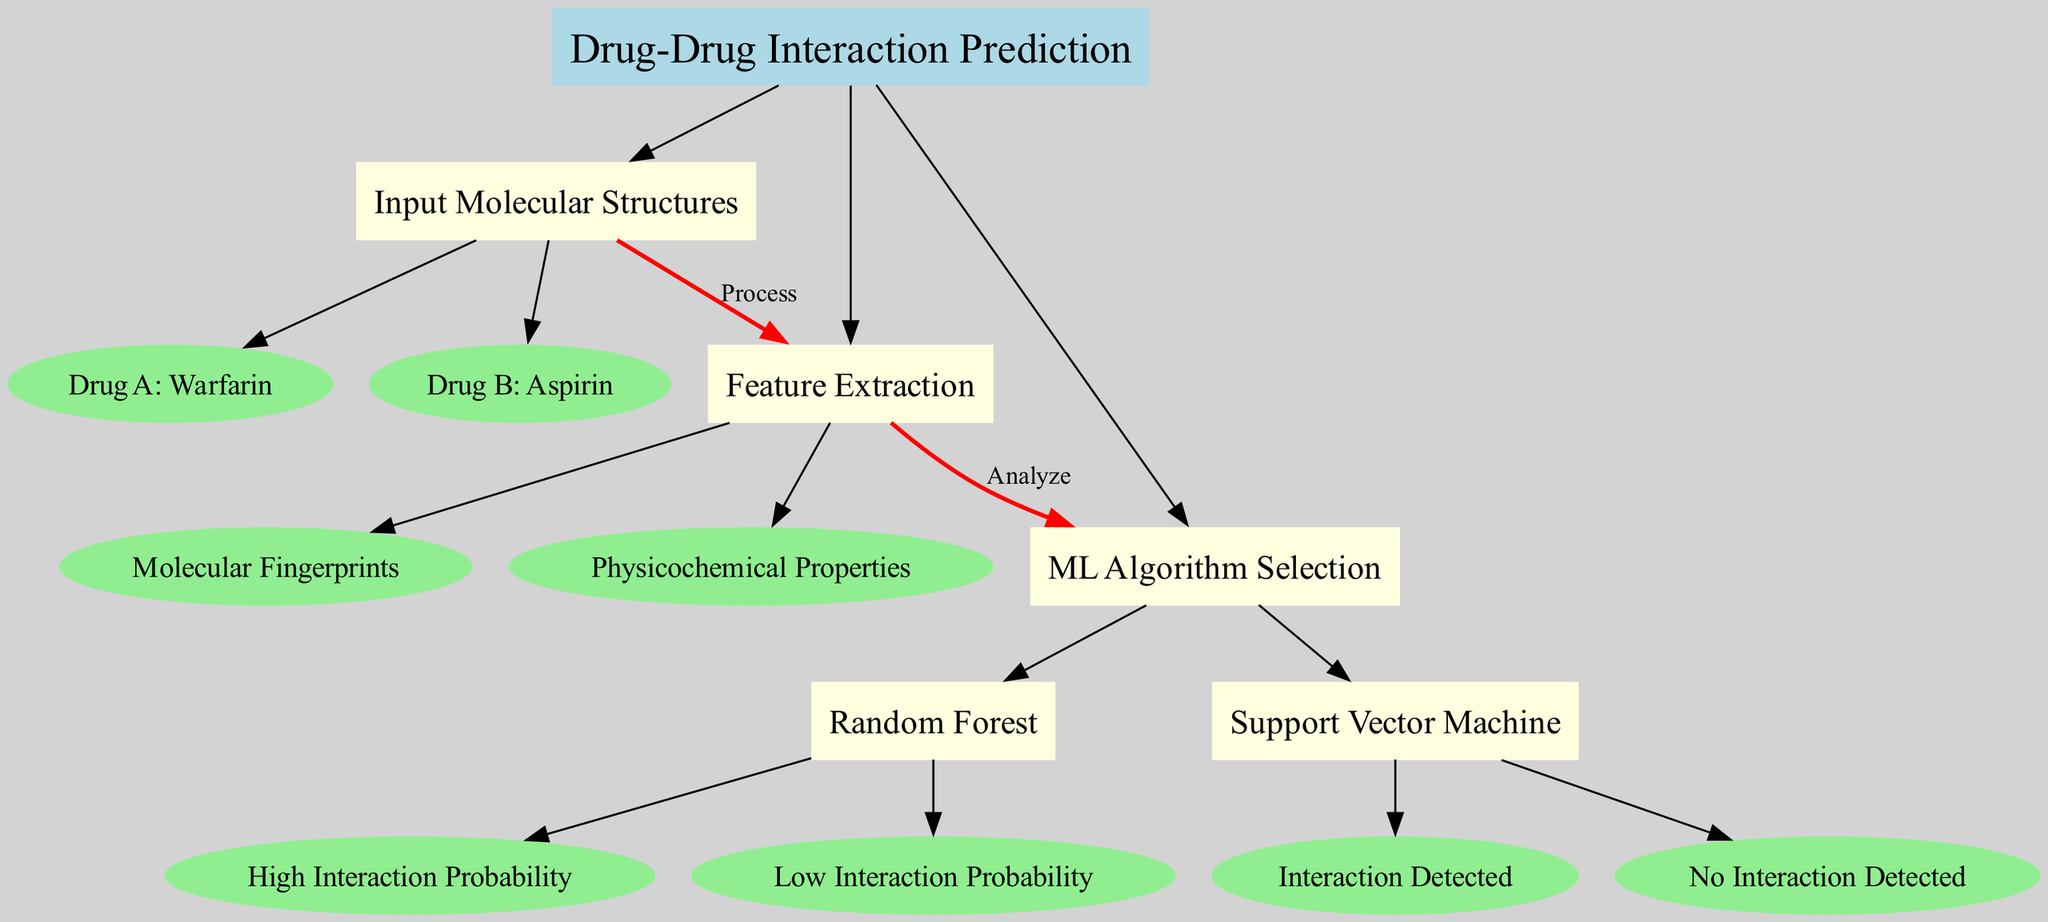What is the root node of the diagram? The root node of the diagram is "Drug-Drug Interaction Prediction", which acts as the starting point for the process illustrated.
Answer: Drug-Drug Interaction Prediction How many input molecular structures are there? The diagram specifies two input molecular structures, which are the initial step in the prediction process.
Answer: 2 What is the first step in the process? The diagram indicates that the first step is "Input Molecular Structures", which is crucial for the subsequent analysis phase.
Answer: Input Molecular Structures What type of machine learning algorithm is used after feature extraction? According to the diagram, after feature extraction, the next step is to select a machine learning algorithm, which can be either "Random Forest" or "Support Vector Machine".
Answer: Random Forest and Support Vector Machine What is the outcome of the "Support Vector Machine" node if an interaction is detected? If the "Support Vector Machine" node detects an interaction, it shows the result as "Interaction Detected", indicating a significant finding in drug-drug interaction predictions.
Answer: Interaction Detected What products are compared in the input molecular structures? The input molecular structures labeled in the diagram are Warfarin and Aspirin, representing common drugs that may interact with each other.
Answer: Warfarin and Aspirin How is feature extraction represented in the diagram? Feature extraction is represented as a separate node labeled "Feature Extraction", which includes "Molecular Fingerprints" and "Physicochemical Properties".
Answer: Feature Extraction What indicates a high interaction probability in the Random Forest algorithm? The "Random Forest" node leads to two outcomes, with "High Interaction Probability" indicating a significant likelihood of interaction between the drugs based on the analysis.
Answer: High Interaction Probability What is the relationship between "Feature Extraction" and "ML Algorithm Selection"? The diagram shows a directed edge labeled "Analyze" connecting "Feature Extraction" to "ML Algorithm Selection", indicating that feature extraction is a prerequisite for choosing the machine learning algorithm.
Answer: Analyze 